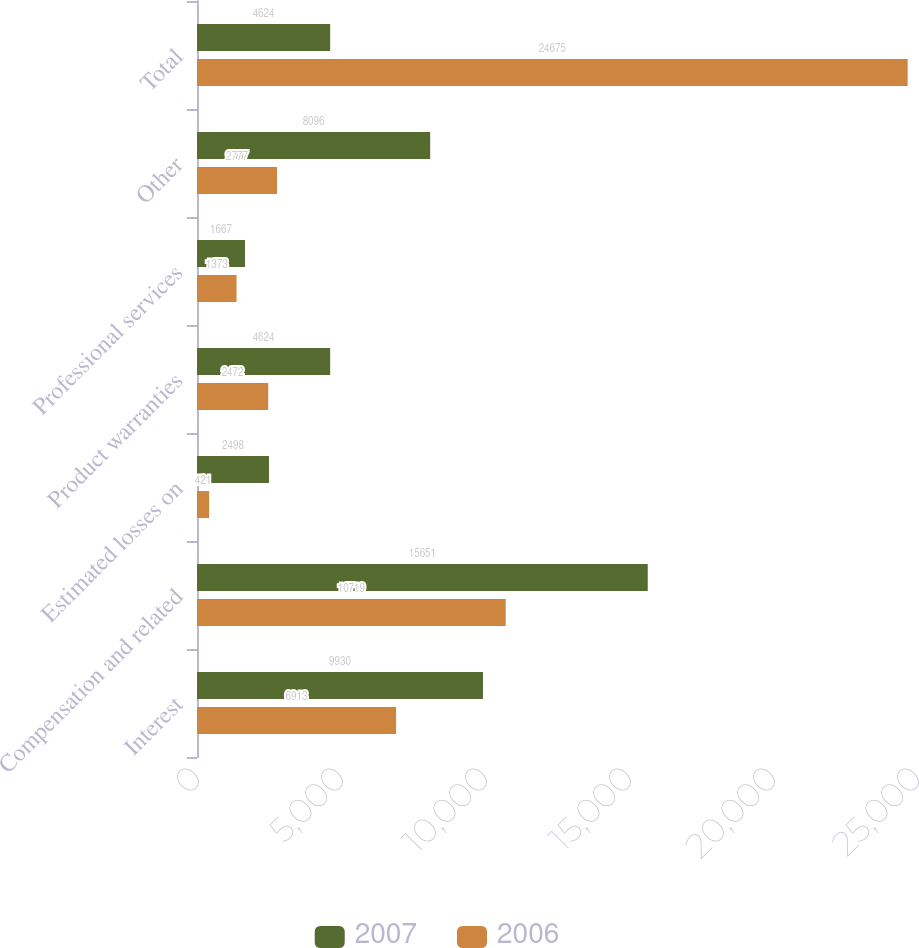<chart> <loc_0><loc_0><loc_500><loc_500><stacked_bar_chart><ecel><fcel>Interest<fcel>Compensation and related<fcel>Estimated losses on<fcel>Product warranties<fcel>Professional services<fcel>Other<fcel>Total<nl><fcel>2007<fcel>9930<fcel>15651<fcel>2498<fcel>4624<fcel>1667<fcel>8096<fcel>4624<nl><fcel>2006<fcel>6913<fcel>10719<fcel>421<fcel>2472<fcel>1373<fcel>2777<fcel>24675<nl></chart> 